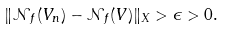Convert formula to latex. <formula><loc_0><loc_0><loc_500><loc_500>\| \mathcal { N } _ { f } ( V _ { n } ) - \mathcal { N } _ { f } ( V ) \| _ { X } > \epsilon > 0 .</formula> 